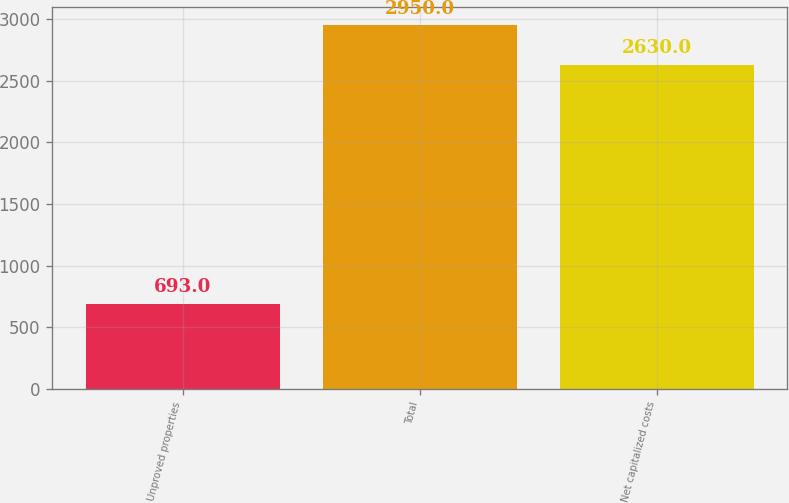<chart> <loc_0><loc_0><loc_500><loc_500><bar_chart><fcel>Unproved properties<fcel>Total<fcel>Net capitalized costs<nl><fcel>693<fcel>2950<fcel>2630<nl></chart> 